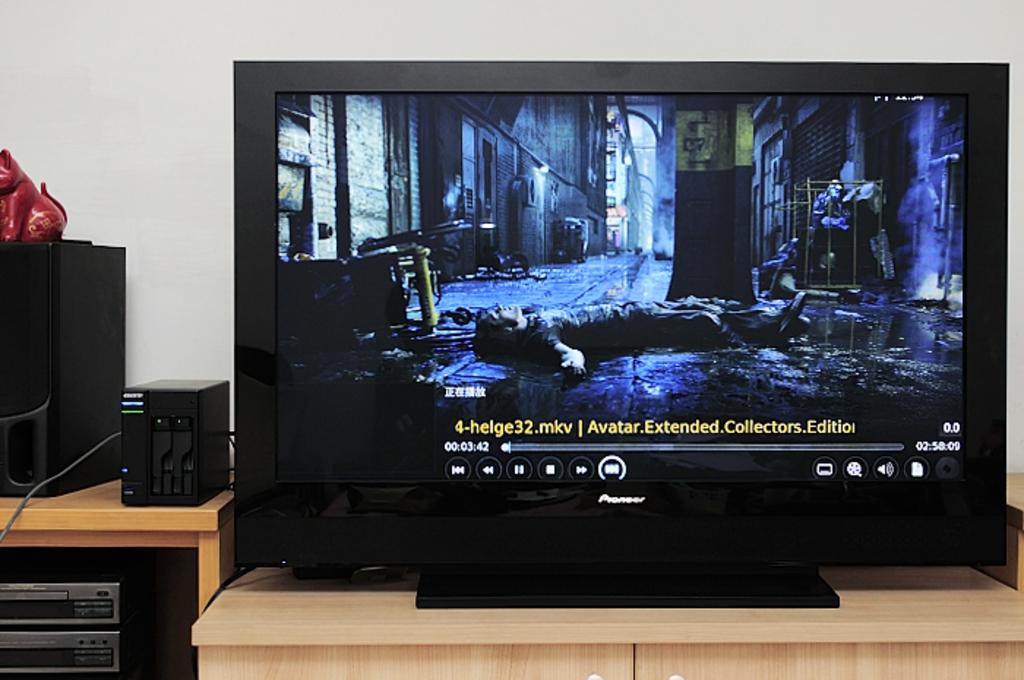<image>
Describe the image concisely. The extended collector's edition of Avatar is playing on a monitor. 